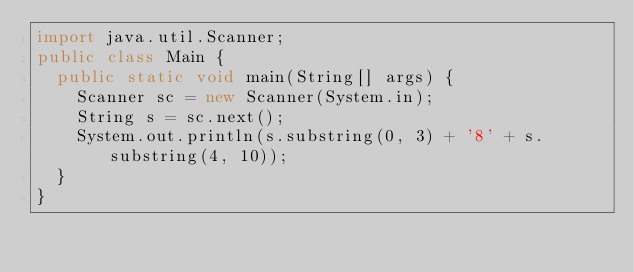Convert code to text. <code><loc_0><loc_0><loc_500><loc_500><_Java_>import java.util.Scanner;
public class Main {
	public static void main(String[] args) {
		Scanner sc = new Scanner(System.in);
		String s = sc.next();
		System.out.println(s.substring(0, 3) + '8' + s.substring(4, 10)); 
	}
}
</code> 